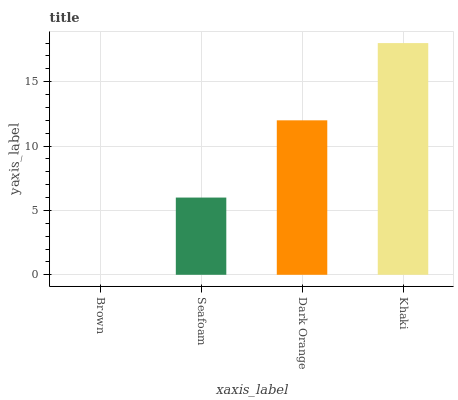Is Brown the minimum?
Answer yes or no. Yes. Is Khaki the maximum?
Answer yes or no. Yes. Is Seafoam the minimum?
Answer yes or no. No. Is Seafoam the maximum?
Answer yes or no. No. Is Seafoam greater than Brown?
Answer yes or no. Yes. Is Brown less than Seafoam?
Answer yes or no. Yes. Is Brown greater than Seafoam?
Answer yes or no. No. Is Seafoam less than Brown?
Answer yes or no. No. Is Dark Orange the high median?
Answer yes or no. Yes. Is Seafoam the low median?
Answer yes or no. Yes. Is Seafoam the high median?
Answer yes or no. No. Is Dark Orange the low median?
Answer yes or no. No. 